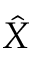Convert formula to latex. <formula><loc_0><loc_0><loc_500><loc_500>\hat { X }</formula> 